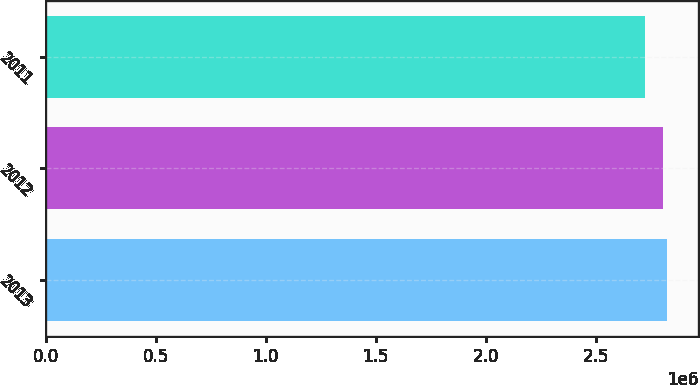<chart> <loc_0><loc_0><loc_500><loc_500><bar_chart><fcel>2013<fcel>2012<fcel>2011<nl><fcel>2.82476e+06<fcel>2.80781e+06<fcel>2.7216e+06<nl></chart> 